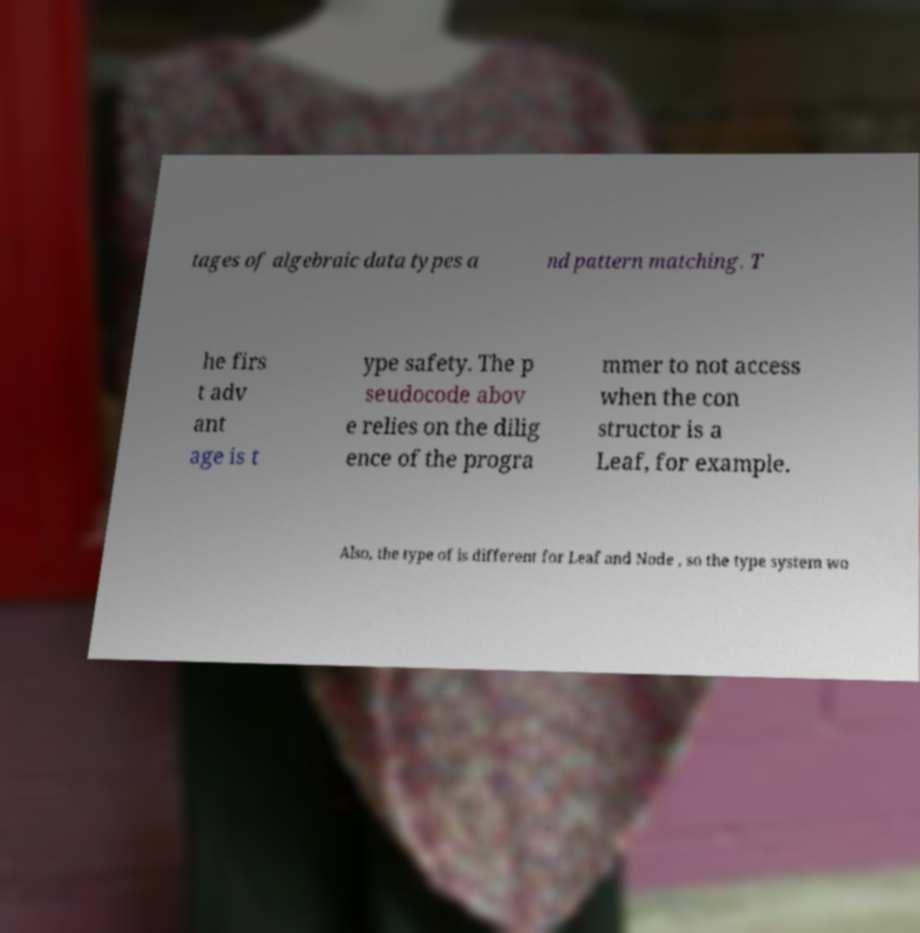I need the written content from this picture converted into text. Can you do that? tages of algebraic data types a nd pattern matching. T he firs t adv ant age is t ype safety. The p seudocode abov e relies on the dilig ence of the progra mmer to not access when the con structor is a Leaf, for example. Also, the type of is different for Leaf and Node , so the type system wo 